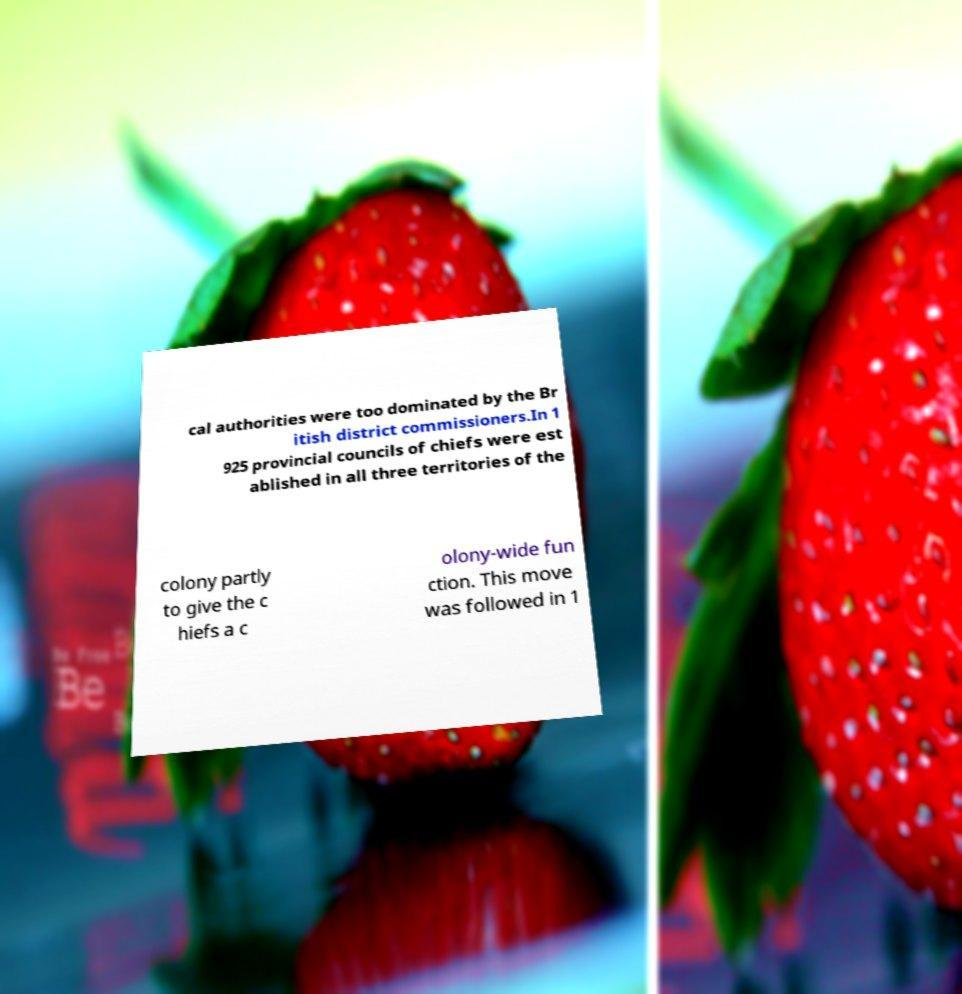Can you accurately transcribe the text from the provided image for me? cal authorities were too dominated by the Br itish district commissioners.In 1 925 provincial councils of chiefs were est ablished in all three territories of the colony partly to give the c hiefs a c olony-wide fun ction. This move was followed in 1 